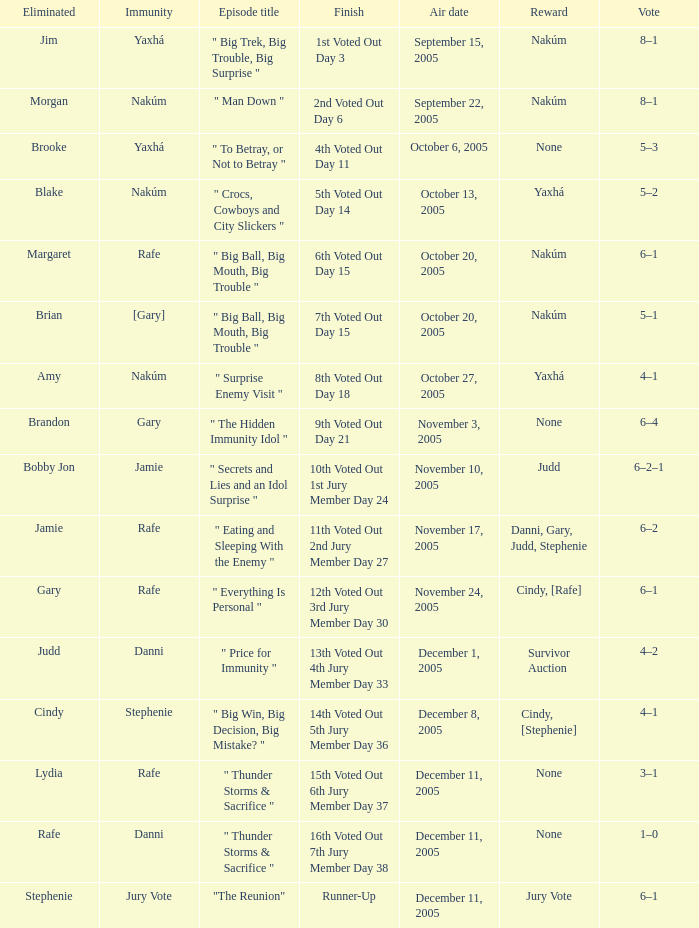How many air dates were there when Morgan was eliminated? 1.0. 